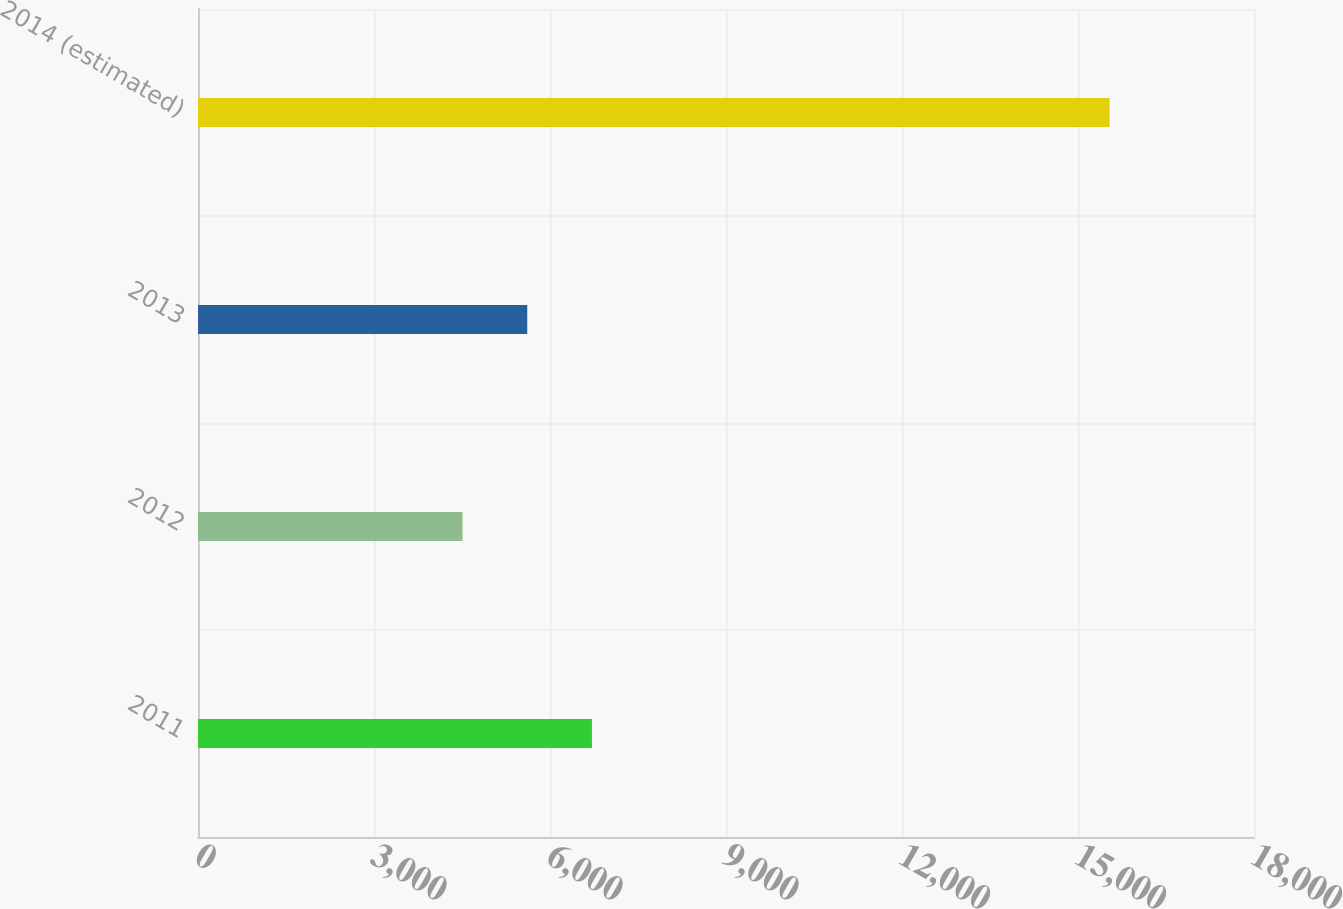<chart> <loc_0><loc_0><loc_500><loc_500><bar_chart><fcel>2011<fcel>2012<fcel>2013<fcel>2014 (estimated)<nl><fcel>6715<fcel>4509<fcel>5612<fcel>15539<nl></chart> 